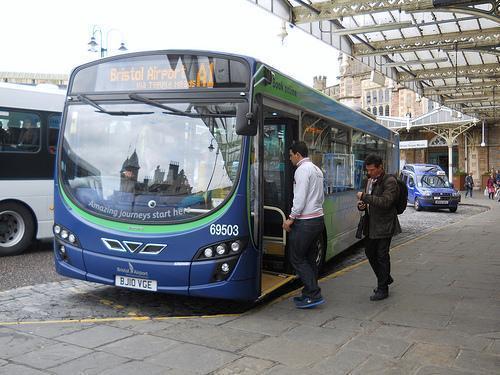How many people are wearing white shirt?
Give a very brief answer. 1. 